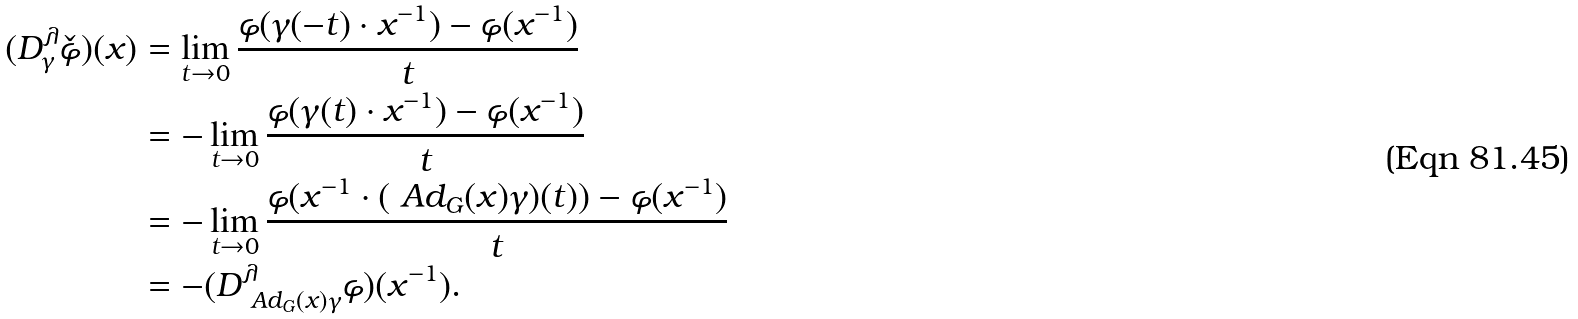Convert formula to latex. <formula><loc_0><loc_0><loc_500><loc_500>( D ^ { \lambda } _ { \gamma } \check { \varphi } ) ( x ) & = \lim _ { t \to 0 } \frac { \varphi ( \gamma ( - t ) \cdot x ^ { - 1 } ) - \varphi ( x ^ { - 1 } ) } { t } \\ & = - \lim _ { t \to 0 } \frac { \varphi ( \gamma ( t ) \cdot x ^ { - 1 } ) - \varphi ( x ^ { - 1 } ) } { t } \\ & = - \lim _ { t \to 0 } \frac { \varphi ( x ^ { - 1 } \cdot ( \ A d _ { G } ( x ) \gamma ) ( t ) ) - \varphi ( x ^ { - 1 } ) } { t } \\ & = - ( D ^ { \lambda } _ { \ A d _ { G } ( x ) \gamma } \varphi ) ( x ^ { - 1 } ) .</formula> 